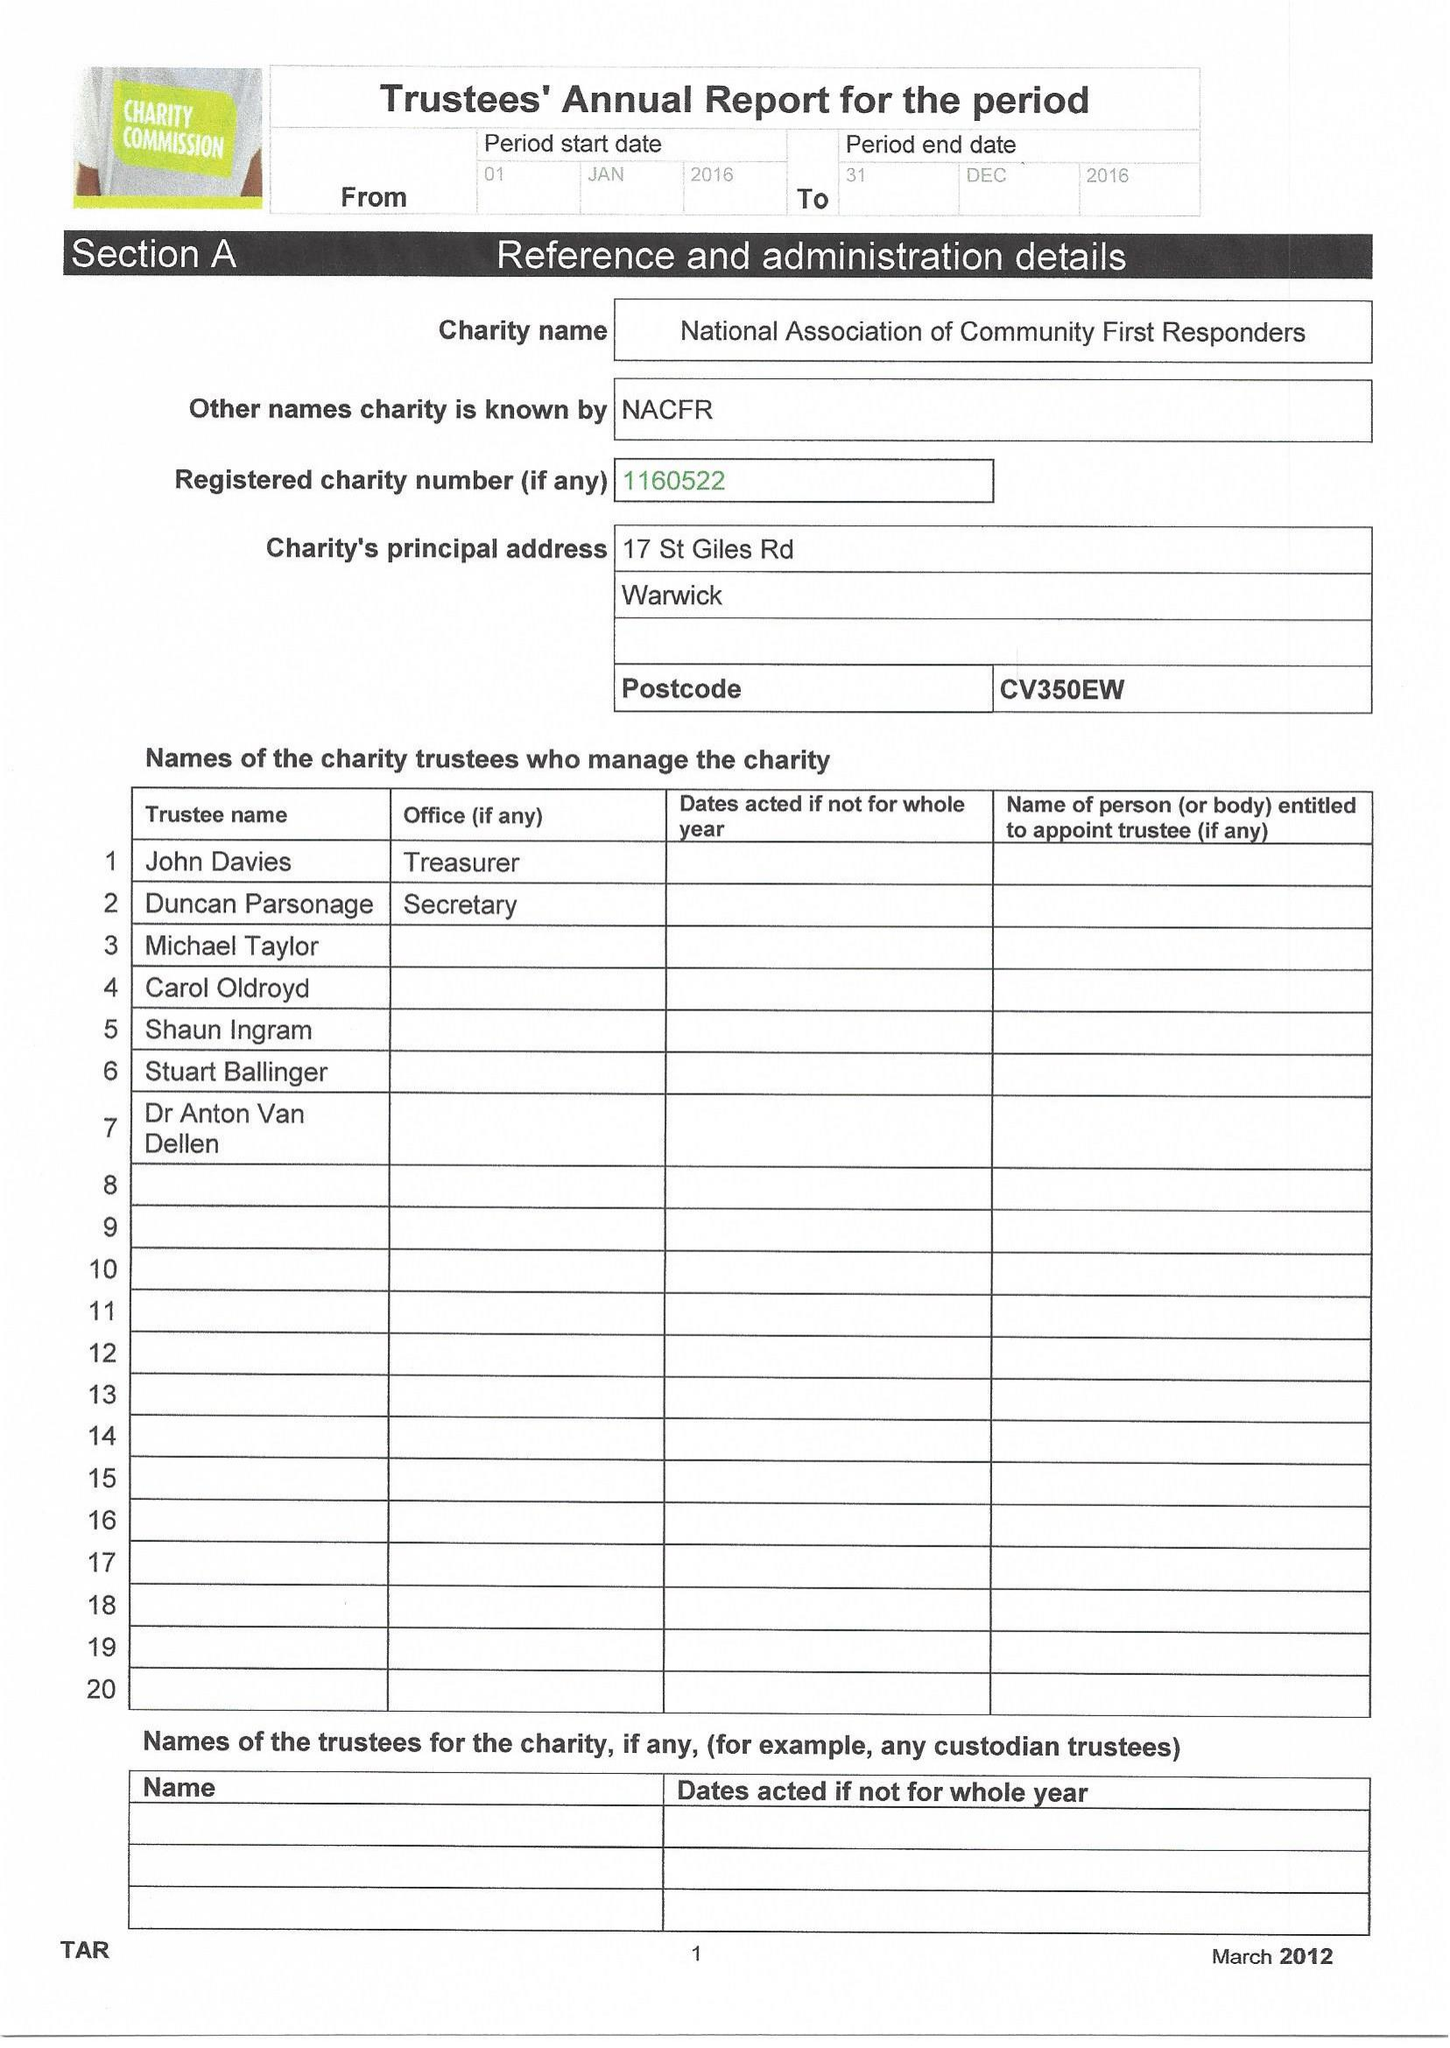What is the value for the report_date?
Answer the question using a single word or phrase. 2016-12-31 